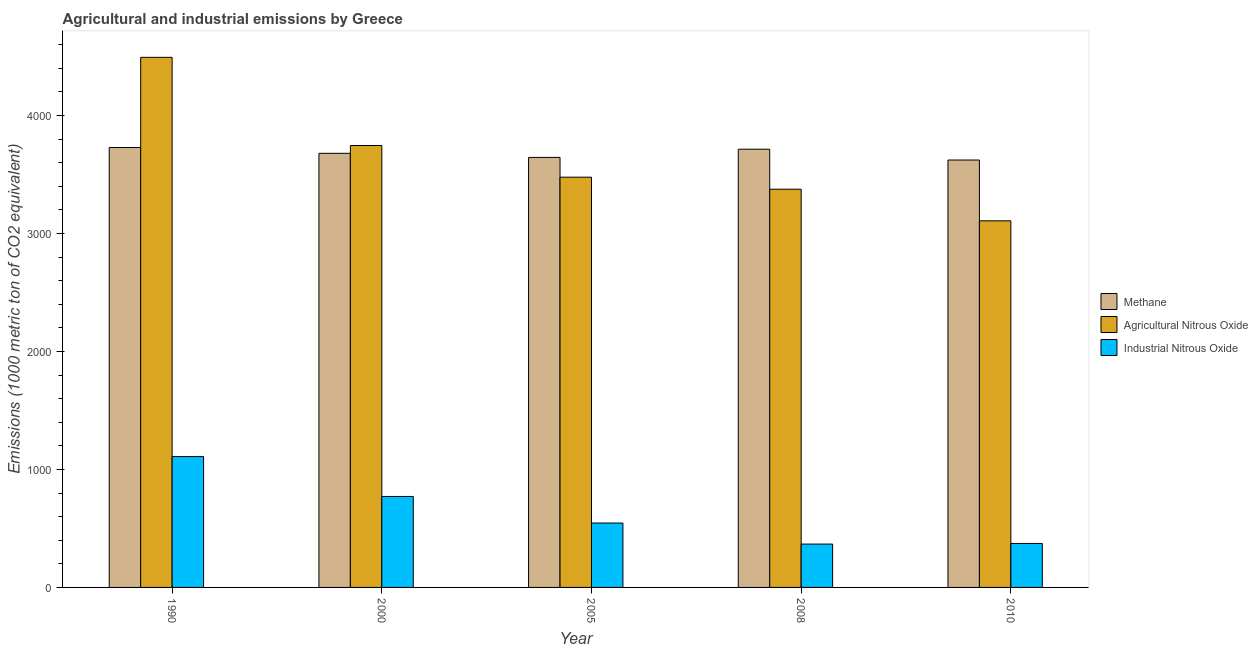How many different coloured bars are there?
Offer a very short reply. 3. Are the number of bars per tick equal to the number of legend labels?
Your answer should be very brief. Yes. How many bars are there on the 1st tick from the right?
Ensure brevity in your answer.  3. In how many cases, is the number of bars for a given year not equal to the number of legend labels?
Ensure brevity in your answer.  0. What is the amount of methane emissions in 2000?
Your answer should be very brief. 3679.3. Across all years, what is the maximum amount of agricultural nitrous oxide emissions?
Keep it short and to the point. 4492.8. Across all years, what is the minimum amount of methane emissions?
Give a very brief answer. 3622.4. In which year was the amount of industrial nitrous oxide emissions maximum?
Your answer should be very brief. 1990. In which year was the amount of methane emissions minimum?
Your answer should be very brief. 2010. What is the total amount of agricultural nitrous oxide emissions in the graph?
Provide a short and direct response. 1.82e+04. What is the difference between the amount of agricultural nitrous oxide emissions in 2008 and that in 2010?
Offer a very short reply. 267.9. What is the difference between the amount of methane emissions in 2000 and the amount of agricultural nitrous oxide emissions in 1990?
Provide a short and direct response. -49.2. What is the average amount of methane emissions per year?
Your answer should be very brief. 3677.78. In the year 1990, what is the difference between the amount of methane emissions and amount of industrial nitrous oxide emissions?
Give a very brief answer. 0. What is the ratio of the amount of methane emissions in 2000 to that in 2010?
Your response must be concise. 1.02. Is the amount of industrial nitrous oxide emissions in 1990 less than that in 2008?
Provide a succinct answer. No. Is the difference between the amount of agricultural nitrous oxide emissions in 2008 and 2010 greater than the difference between the amount of methane emissions in 2008 and 2010?
Your answer should be compact. No. What is the difference between the highest and the second highest amount of industrial nitrous oxide emissions?
Give a very brief answer. 338.1. What is the difference between the highest and the lowest amount of agricultural nitrous oxide emissions?
Provide a short and direct response. 1385.7. What does the 1st bar from the left in 2010 represents?
Keep it short and to the point. Methane. What does the 3rd bar from the right in 1990 represents?
Ensure brevity in your answer.  Methane. Is it the case that in every year, the sum of the amount of methane emissions and amount of agricultural nitrous oxide emissions is greater than the amount of industrial nitrous oxide emissions?
Offer a terse response. Yes. How many bars are there?
Give a very brief answer. 15. Are all the bars in the graph horizontal?
Offer a very short reply. No. How many years are there in the graph?
Your response must be concise. 5. Does the graph contain any zero values?
Provide a succinct answer. No. Where does the legend appear in the graph?
Keep it short and to the point. Center right. How many legend labels are there?
Give a very brief answer. 3. How are the legend labels stacked?
Ensure brevity in your answer.  Vertical. What is the title of the graph?
Give a very brief answer. Agricultural and industrial emissions by Greece. Does "Coal sources" appear as one of the legend labels in the graph?
Provide a short and direct response. No. What is the label or title of the Y-axis?
Your response must be concise. Emissions (1000 metric ton of CO2 equivalent). What is the Emissions (1000 metric ton of CO2 equivalent) in Methane in 1990?
Your answer should be very brief. 3728.5. What is the Emissions (1000 metric ton of CO2 equivalent) of Agricultural Nitrous Oxide in 1990?
Keep it short and to the point. 4492.8. What is the Emissions (1000 metric ton of CO2 equivalent) of Industrial Nitrous Oxide in 1990?
Make the answer very short. 1109.1. What is the Emissions (1000 metric ton of CO2 equivalent) in Methane in 2000?
Provide a succinct answer. 3679.3. What is the Emissions (1000 metric ton of CO2 equivalent) of Agricultural Nitrous Oxide in 2000?
Your answer should be compact. 3745.5. What is the Emissions (1000 metric ton of CO2 equivalent) of Industrial Nitrous Oxide in 2000?
Make the answer very short. 771. What is the Emissions (1000 metric ton of CO2 equivalent) in Methane in 2005?
Provide a short and direct response. 3644.6. What is the Emissions (1000 metric ton of CO2 equivalent) of Agricultural Nitrous Oxide in 2005?
Ensure brevity in your answer.  3477. What is the Emissions (1000 metric ton of CO2 equivalent) of Industrial Nitrous Oxide in 2005?
Ensure brevity in your answer.  545.8. What is the Emissions (1000 metric ton of CO2 equivalent) in Methane in 2008?
Your answer should be very brief. 3714.1. What is the Emissions (1000 metric ton of CO2 equivalent) in Agricultural Nitrous Oxide in 2008?
Provide a short and direct response. 3375. What is the Emissions (1000 metric ton of CO2 equivalent) in Industrial Nitrous Oxide in 2008?
Keep it short and to the point. 367.4. What is the Emissions (1000 metric ton of CO2 equivalent) in Methane in 2010?
Your answer should be compact. 3622.4. What is the Emissions (1000 metric ton of CO2 equivalent) in Agricultural Nitrous Oxide in 2010?
Give a very brief answer. 3107.1. What is the Emissions (1000 metric ton of CO2 equivalent) of Industrial Nitrous Oxide in 2010?
Provide a succinct answer. 372.7. Across all years, what is the maximum Emissions (1000 metric ton of CO2 equivalent) of Methane?
Provide a succinct answer. 3728.5. Across all years, what is the maximum Emissions (1000 metric ton of CO2 equivalent) of Agricultural Nitrous Oxide?
Ensure brevity in your answer.  4492.8. Across all years, what is the maximum Emissions (1000 metric ton of CO2 equivalent) in Industrial Nitrous Oxide?
Provide a short and direct response. 1109.1. Across all years, what is the minimum Emissions (1000 metric ton of CO2 equivalent) in Methane?
Your response must be concise. 3622.4. Across all years, what is the minimum Emissions (1000 metric ton of CO2 equivalent) in Agricultural Nitrous Oxide?
Give a very brief answer. 3107.1. Across all years, what is the minimum Emissions (1000 metric ton of CO2 equivalent) of Industrial Nitrous Oxide?
Give a very brief answer. 367.4. What is the total Emissions (1000 metric ton of CO2 equivalent) in Methane in the graph?
Keep it short and to the point. 1.84e+04. What is the total Emissions (1000 metric ton of CO2 equivalent) in Agricultural Nitrous Oxide in the graph?
Ensure brevity in your answer.  1.82e+04. What is the total Emissions (1000 metric ton of CO2 equivalent) of Industrial Nitrous Oxide in the graph?
Provide a short and direct response. 3166. What is the difference between the Emissions (1000 metric ton of CO2 equivalent) of Methane in 1990 and that in 2000?
Your answer should be very brief. 49.2. What is the difference between the Emissions (1000 metric ton of CO2 equivalent) in Agricultural Nitrous Oxide in 1990 and that in 2000?
Provide a succinct answer. 747.3. What is the difference between the Emissions (1000 metric ton of CO2 equivalent) in Industrial Nitrous Oxide in 1990 and that in 2000?
Provide a succinct answer. 338.1. What is the difference between the Emissions (1000 metric ton of CO2 equivalent) of Methane in 1990 and that in 2005?
Your answer should be very brief. 83.9. What is the difference between the Emissions (1000 metric ton of CO2 equivalent) of Agricultural Nitrous Oxide in 1990 and that in 2005?
Your answer should be very brief. 1015.8. What is the difference between the Emissions (1000 metric ton of CO2 equivalent) in Industrial Nitrous Oxide in 1990 and that in 2005?
Provide a short and direct response. 563.3. What is the difference between the Emissions (1000 metric ton of CO2 equivalent) in Methane in 1990 and that in 2008?
Your answer should be very brief. 14.4. What is the difference between the Emissions (1000 metric ton of CO2 equivalent) in Agricultural Nitrous Oxide in 1990 and that in 2008?
Ensure brevity in your answer.  1117.8. What is the difference between the Emissions (1000 metric ton of CO2 equivalent) of Industrial Nitrous Oxide in 1990 and that in 2008?
Your answer should be very brief. 741.7. What is the difference between the Emissions (1000 metric ton of CO2 equivalent) in Methane in 1990 and that in 2010?
Your answer should be compact. 106.1. What is the difference between the Emissions (1000 metric ton of CO2 equivalent) of Agricultural Nitrous Oxide in 1990 and that in 2010?
Ensure brevity in your answer.  1385.7. What is the difference between the Emissions (1000 metric ton of CO2 equivalent) in Industrial Nitrous Oxide in 1990 and that in 2010?
Ensure brevity in your answer.  736.4. What is the difference between the Emissions (1000 metric ton of CO2 equivalent) in Methane in 2000 and that in 2005?
Provide a short and direct response. 34.7. What is the difference between the Emissions (1000 metric ton of CO2 equivalent) in Agricultural Nitrous Oxide in 2000 and that in 2005?
Ensure brevity in your answer.  268.5. What is the difference between the Emissions (1000 metric ton of CO2 equivalent) of Industrial Nitrous Oxide in 2000 and that in 2005?
Provide a succinct answer. 225.2. What is the difference between the Emissions (1000 metric ton of CO2 equivalent) in Methane in 2000 and that in 2008?
Offer a terse response. -34.8. What is the difference between the Emissions (1000 metric ton of CO2 equivalent) of Agricultural Nitrous Oxide in 2000 and that in 2008?
Keep it short and to the point. 370.5. What is the difference between the Emissions (1000 metric ton of CO2 equivalent) of Industrial Nitrous Oxide in 2000 and that in 2008?
Provide a succinct answer. 403.6. What is the difference between the Emissions (1000 metric ton of CO2 equivalent) of Methane in 2000 and that in 2010?
Ensure brevity in your answer.  56.9. What is the difference between the Emissions (1000 metric ton of CO2 equivalent) in Agricultural Nitrous Oxide in 2000 and that in 2010?
Provide a short and direct response. 638.4. What is the difference between the Emissions (1000 metric ton of CO2 equivalent) in Industrial Nitrous Oxide in 2000 and that in 2010?
Your response must be concise. 398.3. What is the difference between the Emissions (1000 metric ton of CO2 equivalent) of Methane in 2005 and that in 2008?
Provide a succinct answer. -69.5. What is the difference between the Emissions (1000 metric ton of CO2 equivalent) in Agricultural Nitrous Oxide in 2005 and that in 2008?
Give a very brief answer. 102. What is the difference between the Emissions (1000 metric ton of CO2 equivalent) in Industrial Nitrous Oxide in 2005 and that in 2008?
Offer a very short reply. 178.4. What is the difference between the Emissions (1000 metric ton of CO2 equivalent) of Agricultural Nitrous Oxide in 2005 and that in 2010?
Give a very brief answer. 369.9. What is the difference between the Emissions (1000 metric ton of CO2 equivalent) in Industrial Nitrous Oxide in 2005 and that in 2010?
Your answer should be compact. 173.1. What is the difference between the Emissions (1000 metric ton of CO2 equivalent) of Methane in 2008 and that in 2010?
Your answer should be compact. 91.7. What is the difference between the Emissions (1000 metric ton of CO2 equivalent) of Agricultural Nitrous Oxide in 2008 and that in 2010?
Provide a succinct answer. 267.9. What is the difference between the Emissions (1000 metric ton of CO2 equivalent) in Industrial Nitrous Oxide in 2008 and that in 2010?
Offer a very short reply. -5.3. What is the difference between the Emissions (1000 metric ton of CO2 equivalent) in Methane in 1990 and the Emissions (1000 metric ton of CO2 equivalent) in Industrial Nitrous Oxide in 2000?
Your answer should be compact. 2957.5. What is the difference between the Emissions (1000 metric ton of CO2 equivalent) of Agricultural Nitrous Oxide in 1990 and the Emissions (1000 metric ton of CO2 equivalent) of Industrial Nitrous Oxide in 2000?
Your answer should be very brief. 3721.8. What is the difference between the Emissions (1000 metric ton of CO2 equivalent) of Methane in 1990 and the Emissions (1000 metric ton of CO2 equivalent) of Agricultural Nitrous Oxide in 2005?
Provide a succinct answer. 251.5. What is the difference between the Emissions (1000 metric ton of CO2 equivalent) in Methane in 1990 and the Emissions (1000 metric ton of CO2 equivalent) in Industrial Nitrous Oxide in 2005?
Offer a very short reply. 3182.7. What is the difference between the Emissions (1000 metric ton of CO2 equivalent) of Agricultural Nitrous Oxide in 1990 and the Emissions (1000 metric ton of CO2 equivalent) of Industrial Nitrous Oxide in 2005?
Your answer should be compact. 3947. What is the difference between the Emissions (1000 metric ton of CO2 equivalent) of Methane in 1990 and the Emissions (1000 metric ton of CO2 equivalent) of Agricultural Nitrous Oxide in 2008?
Your answer should be very brief. 353.5. What is the difference between the Emissions (1000 metric ton of CO2 equivalent) in Methane in 1990 and the Emissions (1000 metric ton of CO2 equivalent) in Industrial Nitrous Oxide in 2008?
Provide a succinct answer. 3361.1. What is the difference between the Emissions (1000 metric ton of CO2 equivalent) in Agricultural Nitrous Oxide in 1990 and the Emissions (1000 metric ton of CO2 equivalent) in Industrial Nitrous Oxide in 2008?
Keep it short and to the point. 4125.4. What is the difference between the Emissions (1000 metric ton of CO2 equivalent) in Methane in 1990 and the Emissions (1000 metric ton of CO2 equivalent) in Agricultural Nitrous Oxide in 2010?
Ensure brevity in your answer.  621.4. What is the difference between the Emissions (1000 metric ton of CO2 equivalent) in Methane in 1990 and the Emissions (1000 metric ton of CO2 equivalent) in Industrial Nitrous Oxide in 2010?
Make the answer very short. 3355.8. What is the difference between the Emissions (1000 metric ton of CO2 equivalent) in Agricultural Nitrous Oxide in 1990 and the Emissions (1000 metric ton of CO2 equivalent) in Industrial Nitrous Oxide in 2010?
Provide a succinct answer. 4120.1. What is the difference between the Emissions (1000 metric ton of CO2 equivalent) of Methane in 2000 and the Emissions (1000 metric ton of CO2 equivalent) of Agricultural Nitrous Oxide in 2005?
Keep it short and to the point. 202.3. What is the difference between the Emissions (1000 metric ton of CO2 equivalent) in Methane in 2000 and the Emissions (1000 metric ton of CO2 equivalent) in Industrial Nitrous Oxide in 2005?
Offer a very short reply. 3133.5. What is the difference between the Emissions (1000 metric ton of CO2 equivalent) in Agricultural Nitrous Oxide in 2000 and the Emissions (1000 metric ton of CO2 equivalent) in Industrial Nitrous Oxide in 2005?
Make the answer very short. 3199.7. What is the difference between the Emissions (1000 metric ton of CO2 equivalent) of Methane in 2000 and the Emissions (1000 metric ton of CO2 equivalent) of Agricultural Nitrous Oxide in 2008?
Provide a succinct answer. 304.3. What is the difference between the Emissions (1000 metric ton of CO2 equivalent) in Methane in 2000 and the Emissions (1000 metric ton of CO2 equivalent) in Industrial Nitrous Oxide in 2008?
Make the answer very short. 3311.9. What is the difference between the Emissions (1000 metric ton of CO2 equivalent) in Agricultural Nitrous Oxide in 2000 and the Emissions (1000 metric ton of CO2 equivalent) in Industrial Nitrous Oxide in 2008?
Give a very brief answer. 3378.1. What is the difference between the Emissions (1000 metric ton of CO2 equivalent) in Methane in 2000 and the Emissions (1000 metric ton of CO2 equivalent) in Agricultural Nitrous Oxide in 2010?
Provide a succinct answer. 572.2. What is the difference between the Emissions (1000 metric ton of CO2 equivalent) of Methane in 2000 and the Emissions (1000 metric ton of CO2 equivalent) of Industrial Nitrous Oxide in 2010?
Keep it short and to the point. 3306.6. What is the difference between the Emissions (1000 metric ton of CO2 equivalent) of Agricultural Nitrous Oxide in 2000 and the Emissions (1000 metric ton of CO2 equivalent) of Industrial Nitrous Oxide in 2010?
Your answer should be compact. 3372.8. What is the difference between the Emissions (1000 metric ton of CO2 equivalent) in Methane in 2005 and the Emissions (1000 metric ton of CO2 equivalent) in Agricultural Nitrous Oxide in 2008?
Offer a terse response. 269.6. What is the difference between the Emissions (1000 metric ton of CO2 equivalent) in Methane in 2005 and the Emissions (1000 metric ton of CO2 equivalent) in Industrial Nitrous Oxide in 2008?
Your answer should be very brief. 3277.2. What is the difference between the Emissions (1000 metric ton of CO2 equivalent) in Agricultural Nitrous Oxide in 2005 and the Emissions (1000 metric ton of CO2 equivalent) in Industrial Nitrous Oxide in 2008?
Offer a very short reply. 3109.6. What is the difference between the Emissions (1000 metric ton of CO2 equivalent) in Methane in 2005 and the Emissions (1000 metric ton of CO2 equivalent) in Agricultural Nitrous Oxide in 2010?
Your response must be concise. 537.5. What is the difference between the Emissions (1000 metric ton of CO2 equivalent) in Methane in 2005 and the Emissions (1000 metric ton of CO2 equivalent) in Industrial Nitrous Oxide in 2010?
Offer a very short reply. 3271.9. What is the difference between the Emissions (1000 metric ton of CO2 equivalent) in Agricultural Nitrous Oxide in 2005 and the Emissions (1000 metric ton of CO2 equivalent) in Industrial Nitrous Oxide in 2010?
Make the answer very short. 3104.3. What is the difference between the Emissions (1000 metric ton of CO2 equivalent) in Methane in 2008 and the Emissions (1000 metric ton of CO2 equivalent) in Agricultural Nitrous Oxide in 2010?
Make the answer very short. 607. What is the difference between the Emissions (1000 metric ton of CO2 equivalent) of Methane in 2008 and the Emissions (1000 metric ton of CO2 equivalent) of Industrial Nitrous Oxide in 2010?
Give a very brief answer. 3341.4. What is the difference between the Emissions (1000 metric ton of CO2 equivalent) of Agricultural Nitrous Oxide in 2008 and the Emissions (1000 metric ton of CO2 equivalent) of Industrial Nitrous Oxide in 2010?
Offer a very short reply. 3002.3. What is the average Emissions (1000 metric ton of CO2 equivalent) of Methane per year?
Keep it short and to the point. 3677.78. What is the average Emissions (1000 metric ton of CO2 equivalent) in Agricultural Nitrous Oxide per year?
Keep it short and to the point. 3639.48. What is the average Emissions (1000 metric ton of CO2 equivalent) in Industrial Nitrous Oxide per year?
Ensure brevity in your answer.  633.2. In the year 1990, what is the difference between the Emissions (1000 metric ton of CO2 equivalent) of Methane and Emissions (1000 metric ton of CO2 equivalent) of Agricultural Nitrous Oxide?
Make the answer very short. -764.3. In the year 1990, what is the difference between the Emissions (1000 metric ton of CO2 equivalent) of Methane and Emissions (1000 metric ton of CO2 equivalent) of Industrial Nitrous Oxide?
Ensure brevity in your answer.  2619.4. In the year 1990, what is the difference between the Emissions (1000 metric ton of CO2 equivalent) of Agricultural Nitrous Oxide and Emissions (1000 metric ton of CO2 equivalent) of Industrial Nitrous Oxide?
Offer a terse response. 3383.7. In the year 2000, what is the difference between the Emissions (1000 metric ton of CO2 equivalent) in Methane and Emissions (1000 metric ton of CO2 equivalent) in Agricultural Nitrous Oxide?
Your response must be concise. -66.2. In the year 2000, what is the difference between the Emissions (1000 metric ton of CO2 equivalent) in Methane and Emissions (1000 metric ton of CO2 equivalent) in Industrial Nitrous Oxide?
Make the answer very short. 2908.3. In the year 2000, what is the difference between the Emissions (1000 metric ton of CO2 equivalent) in Agricultural Nitrous Oxide and Emissions (1000 metric ton of CO2 equivalent) in Industrial Nitrous Oxide?
Make the answer very short. 2974.5. In the year 2005, what is the difference between the Emissions (1000 metric ton of CO2 equivalent) in Methane and Emissions (1000 metric ton of CO2 equivalent) in Agricultural Nitrous Oxide?
Make the answer very short. 167.6. In the year 2005, what is the difference between the Emissions (1000 metric ton of CO2 equivalent) in Methane and Emissions (1000 metric ton of CO2 equivalent) in Industrial Nitrous Oxide?
Make the answer very short. 3098.8. In the year 2005, what is the difference between the Emissions (1000 metric ton of CO2 equivalent) of Agricultural Nitrous Oxide and Emissions (1000 metric ton of CO2 equivalent) of Industrial Nitrous Oxide?
Keep it short and to the point. 2931.2. In the year 2008, what is the difference between the Emissions (1000 metric ton of CO2 equivalent) of Methane and Emissions (1000 metric ton of CO2 equivalent) of Agricultural Nitrous Oxide?
Provide a succinct answer. 339.1. In the year 2008, what is the difference between the Emissions (1000 metric ton of CO2 equivalent) of Methane and Emissions (1000 metric ton of CO2 equivalent) of Industrial Nitrous Oxide?
Your answer should be compact. 3346.7. In the year 2008, what is the difference between the Emissions (1000 metric ton of CO2 equivalent) in Agricultural Nitrous Oxide and Emissions (1000 metric ton of CO2 equivalent) in Industrial Nitrous Oxide?
Your answer should be compact. 3007.6. In the year 2010, what is the difference between the Emissions (1000 metric ton of CO2 equivalent) in Methane and Emissions (1000 metric ton of CO2 equivalent) in Agricultural Nitrous Oxide?
Give a very brief answer. 515.3. In the year 2010, what is the difference between the Emissions (1000 metric ton of CO2 equivalent) in Methane and Emissions (1000 metric ton of CO2 equivalent) in Industrial Nitrous Oxide?
Keep it short and to the point. 3249.7. In the year 2010, what is the difference between the Emissions (1000 metric ton of CO2 equivalent) in Agricultural Nitrous Oxide and Emissions (1000 metric ton of CO2 equivalent) in Industrial Nitrous Oxide?
Provide a succinct answer. 2734.4. What is the ratio of the Emissions (1000 metric ton of CO2 equivalent) in Methane in 1990 to that in 2000?
Your answer should be compact. 1.01. What is the ratio of the Emissions (1000 metric ton of CO2 equivalent) in Agricultural Nitrous Oxide in 1990 to that in 2000?
Your answer should be compact. 1.2. What is the ratio of the Emissions (1000 metric ton of CO2 equivalent) of Industrial Nitrous Oxide in 1990 to that in 2000?
Your answer should be very brief. 1.44. What is the ratio of the Emissions (1000 metric ton of CO2 equivalent) of Methane in 1990 to that in 2005?
Ensure brevity in your answer.  1.02. What is the ratio of the Emissions (1000 metric ton of CO2 equivalent) of Agricultural Nitrous Oxide in 1990 to that in 2005?
Provide a short and direct response. 1.29. What is the ratio of the Emissions (1000 metric ton of CO2 equivalent) in Industrial Nitrous Oxide in 1990 to that in 2005?
Provide a short and direct response. 2.03. What is the ratio of the Emissions (1000 metric ton of CO2 equivalent) of Agricultural Nitrous Oxide in 1990 to that in 2008?
Ensure brevity in your answer.  1.33. What is the ratio of the Emissions (1000 metric ton of CO2 equivalent) of Industrial Nitrous Oxide in 1990 to that in 2008?
Offer a very short reply. 3.02. What is the ratio of the Emissions (1000 metric ton of CO2 equivalent) of Methane in 1990 to that in 2010?
Keep it short and to the point. 1.03. What is the ratio of the Emissions (1000 metric ton of CO2 equivalent) of Agricultural Nitrous Oxide in 1990 to that in 2010?
Give a very brief answer. 1.45. What is the ratio of the Emissions (1000 metric ton of CO2 equivalent) of Industrial Nitrous Oxide in 1990 to that in 2010?
Provide a short and direct response. 2.98. What is the ratio of the Emissions (1000 metric ton of CO2 equivalent) in Methane in 2000 to that in 2005?
Ensure brevity in your answer.  1.01. What is the ratio of the Emissions (1000 metric ton of CO2 equivalent) of Agricultural Nitrous Oxide in 2000 to that in 2005?
Your answer should be compact. 1.08. What is the ratio of the Emissions (1000 metric ton of CO2 equivalent) of Industrial Nitrous Oxide in 2000 to that in 2005?
Ensure brevity in your answer.  1.41. What is the ratio of the Emissions (1000 metric ton of CO2 equivalent) in Methane in 2000 to that in 2008?
Provide a succinct answer. 0.99. What is the ratio of the Emissions (1000 metric ton of CO2 equivalent) of Agricultural Nitrous Oxide in 2000 to that in 2008?
Ensure brevity in your answer.  1.11. What is the ratio of the Emissions (1000 metric ton of CO2 equivalent) in Industrial Nitrous Oxide in 2000 to that in 2008?
Your response must be concise. 2.1. What is the ratio of the Emissions (1000 metric ton of CO2 equivalent) in Methane in 2000 to that in 2010?
Give a very brief answer. 1.02. What is the ratio of the Emissions (1000 metric ton of CO2 equivalent) of Agricultural Nitrous Oxide in 2000 to that in 2010?
Your answer should be compact. 1.21. What is the ratio of the Emissions (1000 metric ton of CO2 equivalent) in Industrial Nitrous Oxide in 2000 to that in 2010?
Your response must be concise. 2.07. What is the ratio of the Emissions (1000 metric ton of CO2 equivalent) in Methane in 2005 to that in 2008?
Your response must be concise. 0.98. What is the ratio of the Emissions (1000 metric ton of CO2 equivalent) in Agricultural Nitrous Oxide in 2005 to that in 2008?
Offer a terse response. 1.03. What is the ratio of the Emissions (1000 metric ton of CO2 equivalent) in Industrial Nitrous Oxide in 2005 to that in 2008?
Your response must be concise. 1.49. What is the ratio of the Emissions (1000 metric ton of CO2 equivalent) in Agricultural Nitrous Oxide in 2005 to that in 2010?
Ensure brevity in your answer.  1.12. What is the ratio of the Emissions (1000 metric ton of CO2 equivalent) in Industrial Nitrous Oxide in 2005 to that in 2010?
Offer a very short reply. 1.46. What is the ratio of the Emissions (1000 metric ton of CO2 equivalent) of Methane in 2008 to that in 2010?
Your answer should be very brief. 1.03. What is the ratio of the Emissions (1000 metric ton of CO2 equivalent) of Agricultural Nitrous Oxide in 2008 to that in 2010?
Offer a terse response. 1.09. What is the ratio of the Emissions (1000 metric ton of CO2 equivalent) of Industrial Nitrous Oxide in 2008 to that in 2010?
Your answer should be very brief. 0.99. What is the difference between the highest and the second highest Emissions (1000 metric ton of CO2 equivalent) of Methane?
Offer a very short reply. 14.4. What is the difference between the highest and the second highest Emissions (1000 metric ton of CO2 equivalent) in Agricultural Nitrous Oxide?
Your response must be concise. 747.3. What is the difference between the highest and the second highest Emissions (1000 metric ton of CO2 equivalent) of Industrial Nitrous Oxide?
Make the answer very short. 338.1. What is the difference between the highest and the lowest Emissions (1000 metric ton of CO2 equivalent) in Methane?
Your answer should be very brief. 106.1. What is the difference between the highest and the lowest Emissions (1000 metric ton of CO2 equivalent) in Agricultural Nitrous Oxide?
Offer a terse response. 1385.7. What is the difference between the highest and the lowest Emissions (1000 metric ton of CO2 equivalent) in Industrial Nitrous Oxide?
Offer a terse response. 741.7. 